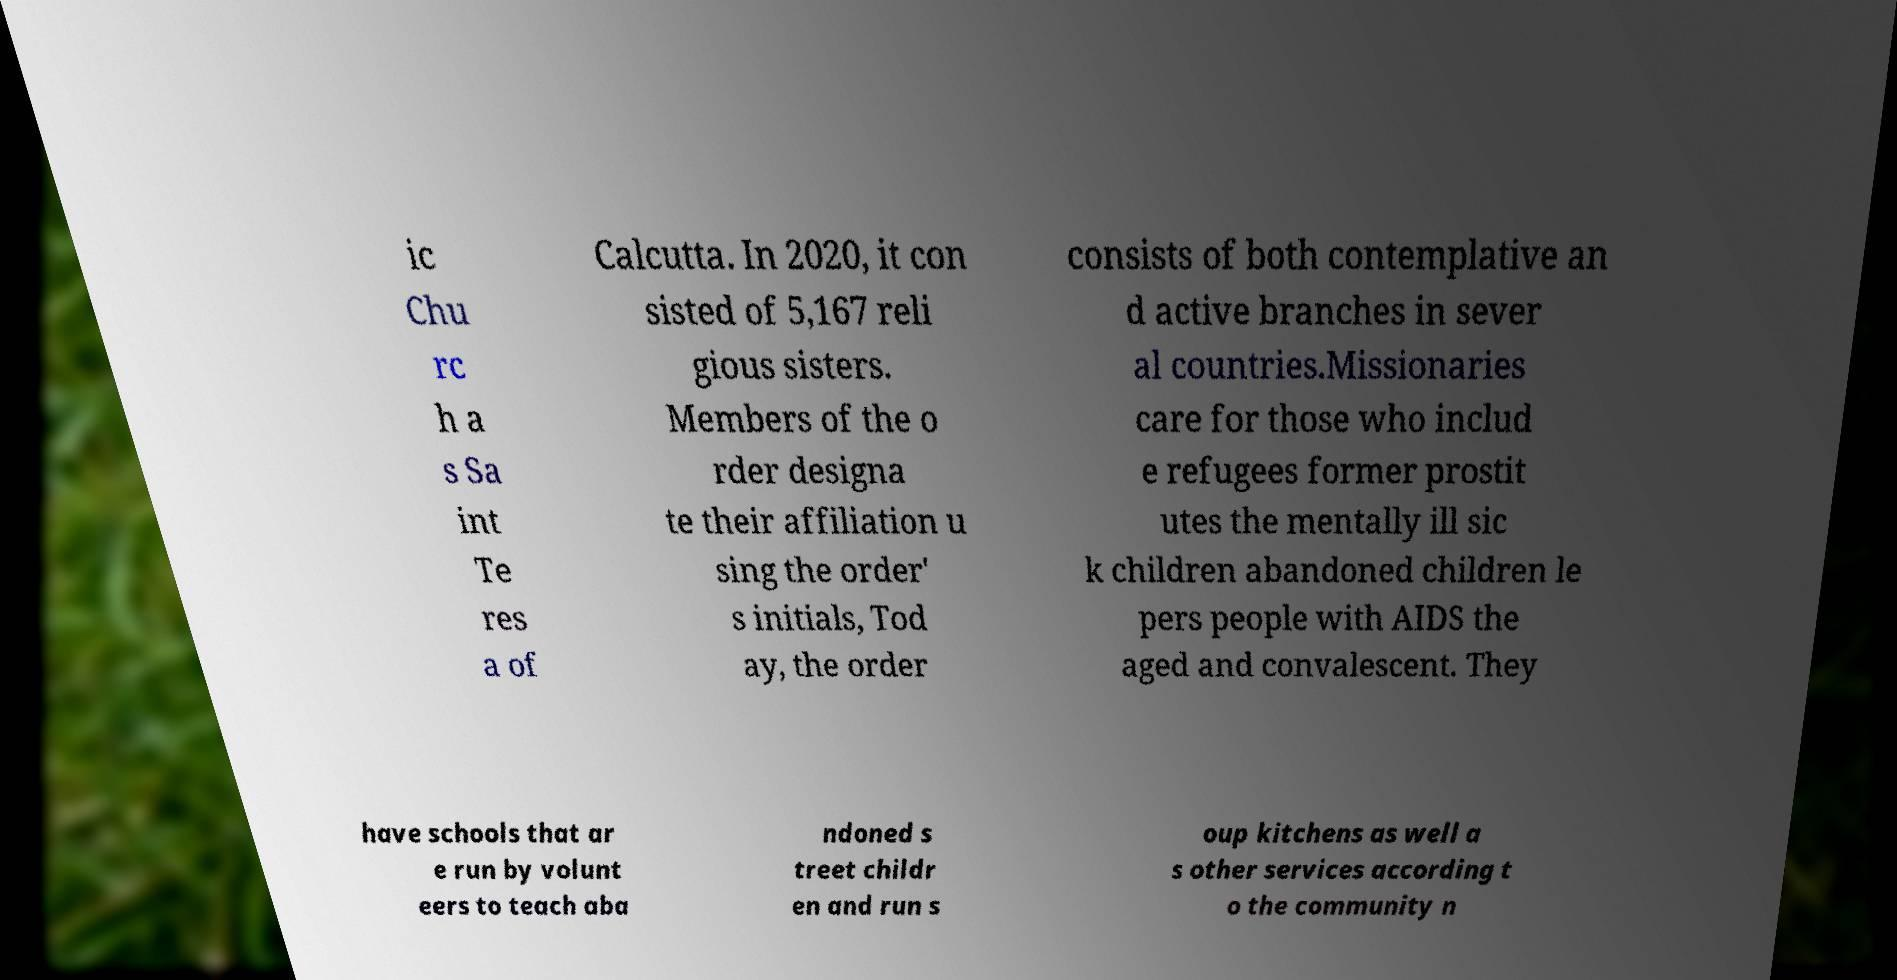I need the written content from this picture converted into text. Can you do that? ic Chu rc h a s Sa int Te res a of Calcutta. In 2020, it con sisted of 5,167 reli gious sisters. Members of the o rder designa te their affiliation u sing the order' s initials, Tod ay, the order consists of both contemplative an d active branches in sever al countries.Missionaries care for those who includ e refugees former prostit utes the mentally ill sic k children abandoned children le pers people with AIDS the aged and convalescent. They have schools that ar e run by volunt eers to teach aba ndoned s treet childr en and run s oup kitchens as well a s other services according t o the community n 